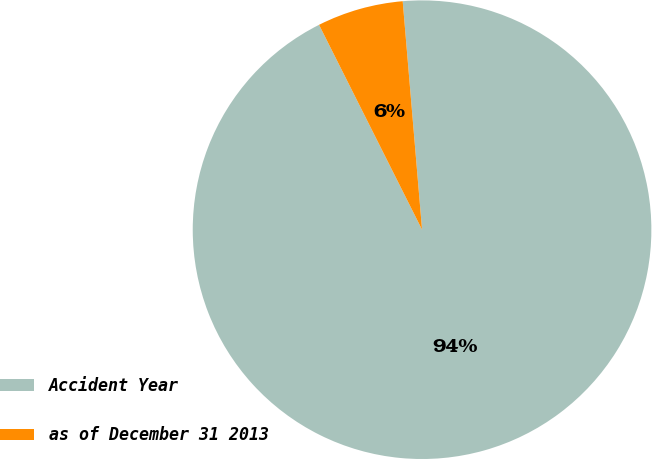Convert chart to OTSL. <chart><loc_0><loc_0><loc_500><loc_500><pie_chart><fcel>Accident Year<fcel>as of December 31 2013<nl><fcel>93.93%<fcel>6.07%<nl></chart> 